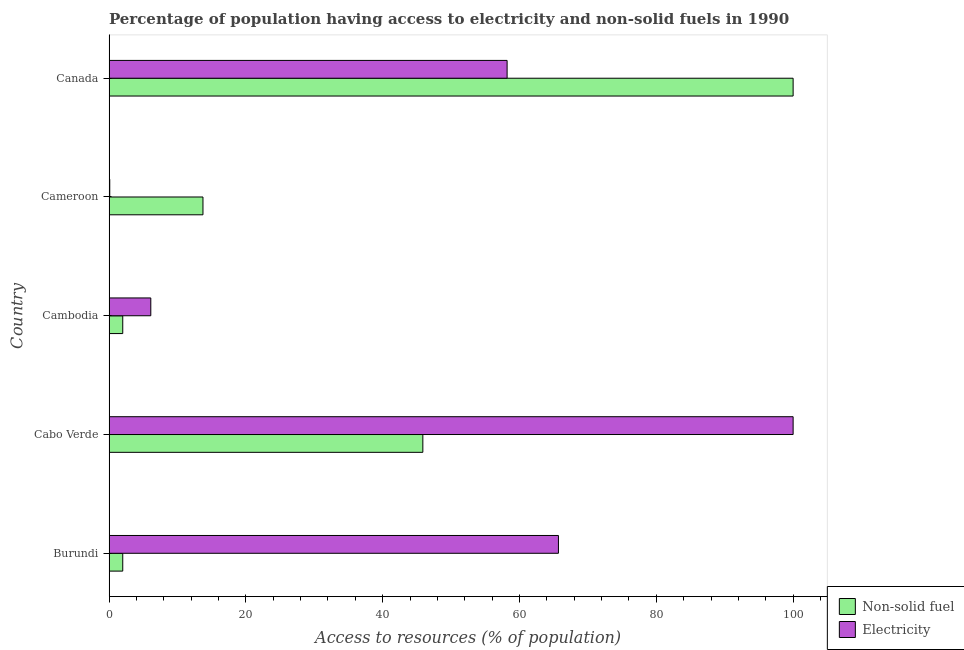How many different coloured bars are there?
Give a very brief answer. 2. How many groups of bars are there?
Give a very brief answer. 5. Are the number of bars on each tick of the Y-axis equal?
Keep it short and to the point. Yes. How many bars are there on the 4th tick from the top?
Provide a short and direct response. 2. What is the percentage of population having access to non-solid fuel in Canada?
Give a very brief answer. 100. Across all countries, what is the maximum percentage of population having access to non-solid fuel?
Your answer should be compact. 100. Across all countries, what is the minimum percentage of population having access to non-solid fuel?
Provide a succinct answer. 2. In which country was the percentage of population having access to non-solid fuel maximum?
Offer a terse response. Canada. In which country was the percentage of population having access to non-solid fuel minimum?
Offer a terse response. Burundi. What is the total percentage of population having access to non-solid fuel in the graph?
Your response must be concise. 163.6. What is the difference between the percentage of population having access to non-solid fuel in Cabo Verde and that in Cambodia?
Your answer should be compact. 43.87. What is the difference between the percentage of population having access to electricity in Canada and the percentage of population having access to non-solid fuel in Cabo Verde?
Make the answer very short. 12.32. What is the average percentage of population having access to non-solid fuel per country?
Give a very brief answer. 32.72. What is the difference between the percentage of population having access to electricity and percentage of population having access to non-solid fuel in Cambodia?
Ensure brevity in your answer.  4.1. In how many countries, is the percentage of population having access to electricity greater than 92 %?
Keep it short and to the point. 1. What is the ratio of the percentage of population having access to non-solid fuel in Cameroon to that in Canada?
Ensure brevity in your answer.  0.14. What is the difference between the highest and the second highest percentage of population having access to electricity?
Make the answer very short. 34.31. What is the difference between the highest and the lowest percentage of population having access to electricity?
Offer a very short reply. 99.9. Is the sum of the percentage of population having access to non-solid fuel in Cambodia and Canada greater than the maximum percentage of population having access to electricity across all countries?
Keep it short and to the point. Yes. What does the 2nd bar from the top in Burundi represents?
Provide a short and direct response. Non-solid fuel. What does the 2nd bar from the bottom in Burundi represents?
Offer a terse response. Electricity. Are all the bars in the graph horizontal?
Offer a terse response. Yes. Does the graph contain any zero values?
Make the answer very short. No. What is the title of the graph?
Your answer should be compact. Percentage of population having access to electricity and non-solid fuels in 1990. Does "Non-residents" appear as one of the legend labels in the graph?
Provide a succinct answer. No. What is the label or title of the X-axis?
Your answer should be very brief. Access to resources (% of population). What is the label or title of the Y-axis?
Your response must be concise. Country. What is the Access to resources (% of population) of Non-solid fuel in Burundi?
Your response must be concise. 2. What is the Access to resources (% of population) in Electricity in Burundi?
Provide a succinct answer. 65.69. What is the Access to resources (% of population) in Non-solid fuel in Cabo Verde?
Provide a succinct answer. 45.87. What is the Access to resources (% of population) of Electricity in Cabo Verde?
Provide a succinct answer. 100. What is the Access to resources (% of population) of Non-solid fuel in Cambodia?
Offer a terse response. 2. What is the Access to resources (% of population) in Electricity in Cambodia?
Your response must be concise. 6.1. What is the Access to resources (% of population) of Non-solid fuel in Cameroon?
Give a very brief answer. 13.73. What is the Access to resources (% of population) in Electricity in Cameroon?
Your response must be concise. 0.1. What is the Access to resources (% of population) in Non-solid fuel in Canada?
Your response must be concise. 100. What is the Access to resources (% of population) of Electricity in Canada?
Make the answer very short. 58.19. Across all countries, what is the minimum Access to resources (% of population) in Non-solid fuel?
Provide a succinct answer. 2. Across all countries, what is the minimum Access to resources (% of population) in Electricity?
Make the answer very short. 0.1. What is the total Access to resources (% of population) of Non-solid fuel in the graph?
Ensure brevity in your answer.  163.6. What is the total Access to resources (% of population) in Electricity in the graph?
Your answer should be compact. 230.08. What is the difference between the Access to resources (% of population) of Non-solid fuel in Burundi and that in Cabo Verde?
Offer a terse response. -43.87. What is the difference between the Access to resources (% of population) of Electricity in Burundi and that in Cabo Verde?
Your answer should be very brief. -34.31. What is the difference between the Access to resources (% of population) of Electricity in Burundi and that in Cambodia?
Offer a terse response. 59.59. What is the difference between the Access to resources (% of population) of Non-solid fuel in Burundi and that in Cameroon?
Your answer should be very brief. -11.73. What is the difference between the Access to resources (% of population) of Electricity in Burundi and that in Cameroon?
Offer a very short reply. 65.59. What is the difference between the Access to resources (% of population) in Non-solid fuel in Burundi and that in Canada?
Give a very brief answer. -98. What is the difference between the Access to resources (% of population) in Electricity in Burundi and that in Canada?
Your answer should be compact. 7.5. What is the difference between the Access to resources (% of population) of Non-solid fuel in Cabo Verde and that in Cambodia?
Provide a succinct answer. 43.87. What is the difference between the Access to resources (% of population) in Electricity in Cabo Verde and that in Cambodia?
Offer a very short reply. 93.9. What is the difference between the Access to resources (% of population) of Non-solid fuel in Cabo Verde and that in Cameroon?
Provide a short and direct response. 32.14. What is the difference between the Access to resources (% of population) of Electricity in Cabo Verde and that in Cameroon?
Provide a succinct answer. 99.9. What is the difference between the Access to resources (% of population) of Non-solid fuel in Cabo Verde and that in Canada?
Your answer should be compact. -54.13. What is the difference between the Access to resources (% of population) of Electricity in Cabo Verde and that in Canada?
Keep it short and to the point. 41.81. What is the difference between the Access to resources (% of population) in Non-solid fuel in Cambodia and that in Cameroon?
Your answer should be compact. -11.73. What is the difference between the Access to resources (% of population) of Non-solid fuel in Cambodia and that in Canada?
Your answer should be very brief. -98. What is the difference between the Access to resources (% of population) of Electricity in Cambodia and that in Canada?
Give a very brief answer. -52.09. What is the difference between the Access to resources (% of population) of Non-solid fuel in Cameroon and that in Canada?
Provide a short and direct response. -86.27. What is the difference between the Access to resources (% of population) in Electricity in Cameroon and that in Canada?
Make the answer very short. -58.09. What is the difference between the Access to resources (% of population) of Non-solid fuel in Burundi and the Access to resources (% of population) of Electricity in Cabo Verde?
Provide a succinct answer. -98. What is the difference between the Access to resources (% of population) of Non-solid fuel in Burundi and the Access to resources (% of population) of Electricity in Cambodia?
Offer a terse response. -4.1. What is the difference between the Access to resources (% of population) in Non-solid fuel in Burundi and the Access to resources (% of population) in Electricity in Canada?
Keep it short and to the point. -56.19. What is the difference between the Access to resources (% of population) of Non-solid fuel in Cabo Verde and the Access to resources (% of population) of Electricity in Cambodia?
Make the answer very short. 39.77. What is the difference between the Access to resources (% of population) in Non-solid fuel in Cabo Verde and the Access to resources (% of population) in Electricity in Cameroon?
Provide a succinct answer. 45.77. What is the difference between the Access to resources (% of population) in Non-solid fuel in Cabo Verde and the Access to resources (% of population) in Electricity in Canada?
Offer a terse response. -12.32. What is the difference between the Access to resources (% of population) of Non-solid fuel in Cambodia and the Access to resources (% of population) of Electricity in Cameroon?
Offer a very short reply. 1.9. What is the difference between the Access to resources (% of population) in Non-solid fuel in Cambodia and the Access to resources (% of population) in Electricity in Canada?
Your response must be concise. -56.19. What is the difference between the Access to resources (% of population) of Non-solid fuel in Cameroon and the Access to resources (% of population) of Electricity in Canada?
Ensure brevity in your answer.  -44.46. What is the average Access to resources (% of population) in Non-solid fuel per country?
Keep it short and to the point. 32.72. What is the average Access to resources (% of population) in Electricity per country?
Your answer should be very brief. 46.02. What is the difference between the Access to resources (% of population) of Non-solid fuel and Access to resources (% of population) of Electricity in Burundi?
Offer a very short reply. -63.69. What is the difference between the Access to resources (% of population) of Non-solid fuel and Access to resources (% of population) of Electricity in Cabo Verde?
Keep it short and to the point. -54.13. What is the difference between the Access to resources (% of population) of Non-solid fuel and Access to resources (% of population) of Electricity in Cambodia?
Offer a terse response. -4.1. What is the difference between the Access to resources (% of population) in Non-solid fuel and Access to resources (% of population) in Electricity in Cameroon?
Your answer should be compact. 13.63. What is the difference between the Access to resources (% of population) in Non-solid fuel and Access to resources (% of population) in Electricity in Canada?
Your response must be concise. 41.81. What is the ratio of the Access to resources (% of population) in Non-solid fuel in Burundi to that in Cabo Verde?
Give a very brief answer. 0.04. What is the ratio of the Access to resources (% of population) of Electricity in Burundi to that in Cabo Verde?
Offer a terse response. 0.66. What is the ratio of the Access to resources (% of population) of Electricity in Burundi to that in Cambodia?
Your answer should be compact. 10.77. What is the ratio of the Access to resources (% of population) in Non-solid fuel in Burundi to that in Cameroon?
Your response must be concise. 0.15. What is the ratio of the Access to resources (% of population) of Electricity in Burundi to that in Cameroon?
Offer a very short reply. 656.91. What is the ratio of the Access to resources (% of population) of Electricity in Burundi to that in Canada?
Provide a succinct answer. 1.13. What is the ratio of the Access to resources (% of population) of Non-solid fuel in Cabo Verde to that in Cambodia?
Your answer should be very brief. 22.93. What is the ratio of the Access to resources (% of population) in Electricity in Cabo Verde to that in Cambodia?
Offer a terse response. 16.39. What is the ratio of the Access to resources (% of population) of Non-solid fuel in Cabo Verde to that in Cameroon?
Provide a short and direct response. 3.34. What is the ratio of the Access to resources (% of population) in Non-solid fuel in Cabo Verde to that in Canada?
Keep it short and to the point. 0.46. What is the ratio of the Access to resources (% of population) in Electricity in Cabo Verde to that in Canada?
Your answer should be very brief. 1.72. What is the ratio of the Access to resources (% of population) of Non-solid fuel in Cambodia to that in Cameroon?
Your answer should be very brief. 0.15. What is the ratio of the Access to resources (% of population) in Electricity in Cambodia to that in Canada?
Your answer should be compact. 0.1. What is the ratio of the Access to resources (% of population) in Non-solid fuel in Cameroon to that in Canada?
Offer a very short reply. 0.14. What is the ratio of the Access to resources (% of population) in Electricity in Cameroon to that in Canada?
Your answer should be compact. 0. What is the difference between the highest and the second highest Access to resources (% of population) of Non-solid fuel?
Offer a terse response. 54.13. What is the difference between the highest and the second highest Access to resources (% of population) of Electricity?
Make the answer very short. 34.31. What is the difference between the highest and the lowest Access to resources (% of population) of Electricity?
Offer a terse response. 99.9. 